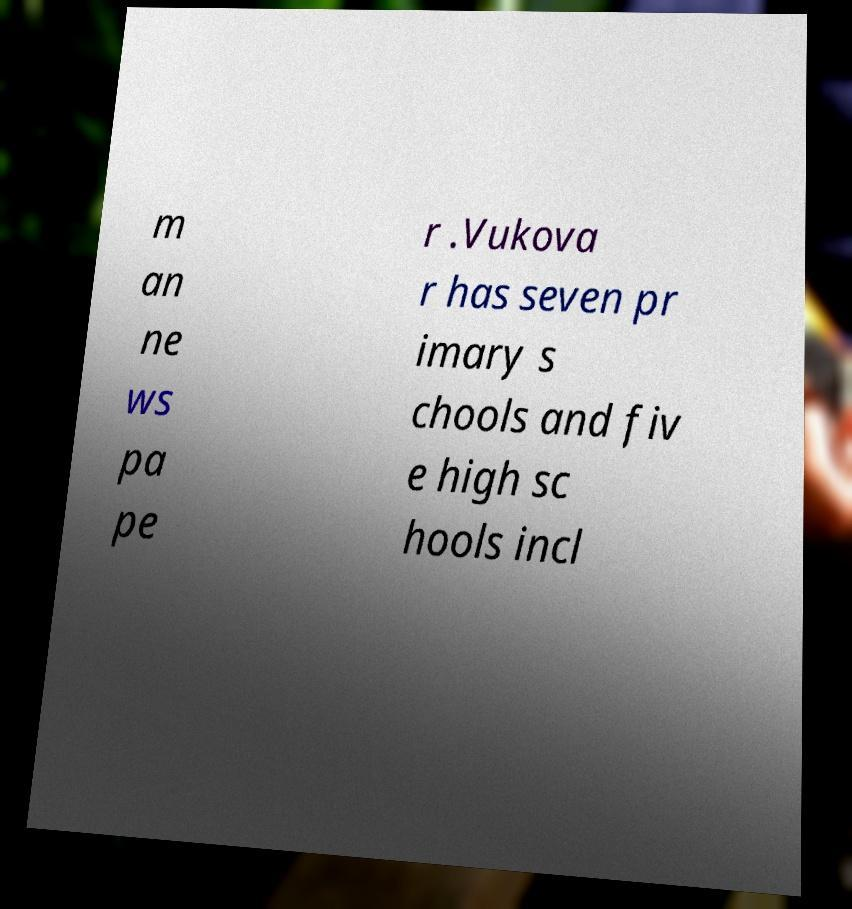I need the written content from this picture converted into text. Can you do that? m an ne ws pa pe r .Vukova r has seven pr imary s chools and fiv e high sc hools incl 